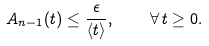<formula> <loc_0><loc_0><loc_500><loc_500>A _ { n - 1 } ( t ) \leq \frac { \epsilon } { \langle t \rangle } , \quad \forall \, t \geq 0 .</formula> 